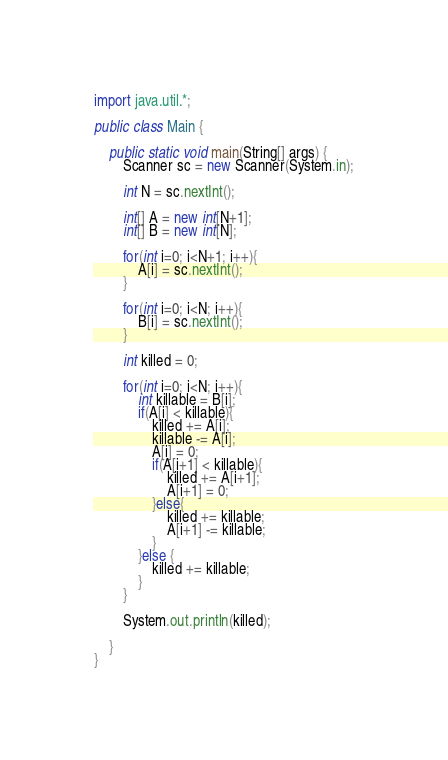Convert code to text. <code><loc_0><loc_0><loc_500><loc_500><_Java_>import java.util.*;

public class Main {

    public static void main(String[] args) {
        Scanner sc = new Scanner(System.in);

        int N = sc.nextInt();

        int[] A = new int[N+1];
        int[] B = new int[N];

        for(int i=0; i<N+1; i++){
            A[i] = sc.nextInt();
        }

        for(int i=0; i<N; i++){
            B[i] = sc.nextInt();
        }

        int killed = 0;

        for(int i=0; i<N; i++){
            int killable = B[i];
            if(A[i] < killable){
                killed += A[i];
                killable -= A[i];
                A[i] = 0;
                if(A[i+1] < killable){
                    killed += A[i+1];
                    A[i+1] = 0;
                }else{
                    killed += killable;
                    A[i+1] -= killable;
                }
            }else {
                killed += killable;
            }
        }

        System.out.println(killed);

    }
}
</code> 